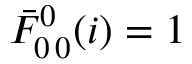<formula> <loc_0><loc_0><loc_500><loc_500>\bar { F } _ { 0 \, 0 } ^ { 0 } ( i ) = 1</formula> 